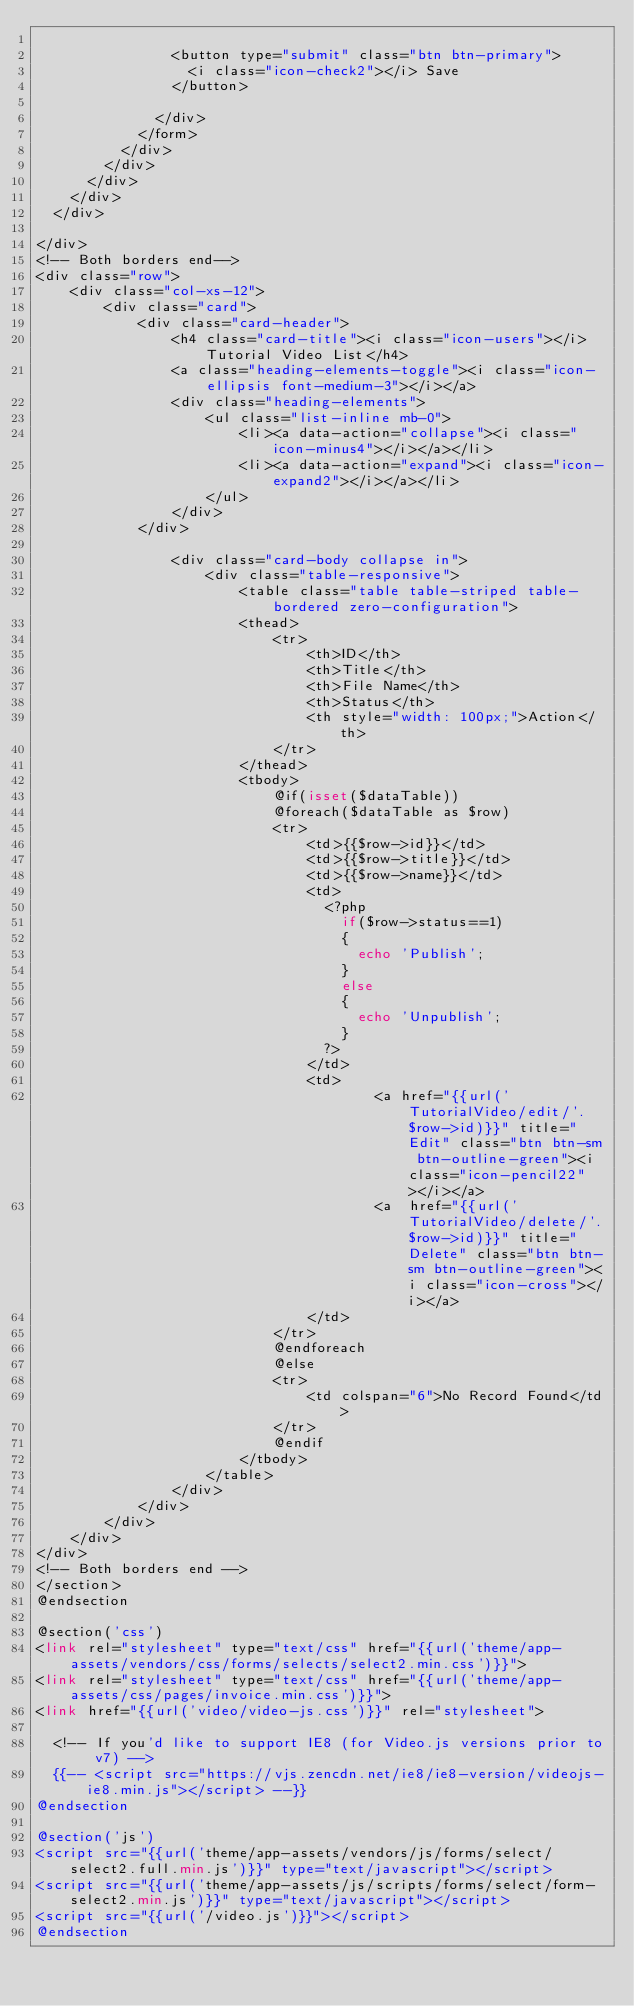<code> <loc_0><loc_0><loc_500><loc_500><_PHP_>								
								<button type="submit" class="btn btn-primary">
									<i class="icon-check2"></i> Save
								</button>
							
							</div>
						</form>
					</div>
				</div>
			</div>
		</div>
	</div>

</div>
<!-- Both borders end-->
<div class="row">
    <div class="col-xs-12">
        <div class="card">
            <div class="card-header">
                <h4 class="card-title"><i class="icon-users"></i> Tutorial Video List</h4>
                <a class="heading-elements-toggle"><i class="icon-ellipsis font-medium-3"></i></a>
                <div class="heading-elements">
                    <ul class="list-inline mb-0">
                        <li><a data-action="collapse"><i class="icon-minus4"></i></a></li>
                        <li><a data-action="expand"><i class="icon-expand2"></i></a></li>
                    </ul>
                </div>
            </div>

                <div class="card-body collapse in">
                    <div class="table-responsive">
                        <table class="table table-striped table-bordered zero-configuration">
                        <thead>
                            <tr>
                                <th>ID</th>
                                <th>Title</th>
                                <th>File Name</th>
                                <th>Status</th>
                                <th style="width: 100px;">Action</th>
                            </tr>
                        </thead>
                        <tbody>
                            @if(isset($dataTable))
                            @foreach($dataTable as $row)
                            <tr>
                                <td>{{$row->id}}</td>
                                <td>{{$row->title}}</td>
                                <td>{{$row->name}}</td>
                                <td>
                                	<?php 
                                		if($row->status==1)
                                		{
                                			echo 'Publish';
                                		}
                                		else
                                		{
                                			echo 'Unpublish';
                                		}
                                	?>
                                </td>
                                <td>
                                        <a href="{{url('TutorialVideo/edit/'.$row->id)}}" title="Edit" class="btn btn-sm btn-outline-green"><i class="icon-pencil22"></i></a>
                                        <a  href="{{url('TutorialVideo/delete/'.$row->id)}}" title="Delete" class="btn btn-sm btn-outline-green"><i class="icon-cross"></i></a>
                                </td>
                            </tr>
                            @endforeach
                            @else
                            <tr>
                                <td colspan="6">No Record Found</td>
                            </tr>
                            @endif
                        </tbody>
                    </table>
                </div>
            </div>
        </div>
    </div>
</div>
<!-- Both borders end -->
</section>
@endsection

@section('css')
<link rel="stylesheet" type="text/css" href="{{url('theme/app-assets/vendors/css/forms/selects/select2.min.css')}}">
<link rel="stylesheet" type="text/css" href="{{url('theme/app-assets/css/pages/invoice.min.css')}}">
<link href="{{url('video/video-js.css')}}" rel="stylesheet">

  <!-- If you'd like to support IE8 (for Video.js versions prior to v7) -->
  {{-- <script src="https://vjs.zencdn.net/ie8/ie8-version/videojs-ie8.min.js"></script> --}}
@endsection

@section('js')
<script src="{{url('theme/app-assets/vendors/js/forms/select/select2.full.min.js')}}" type="text/javascript"></script>
<script src="{{url('theme/app-assets/js/scripts/forms/select/form-select2.min.js')}}" type="text/javascript"></script>
<script src="{{url('/video.js')}}"></script>
@endsection</code> 